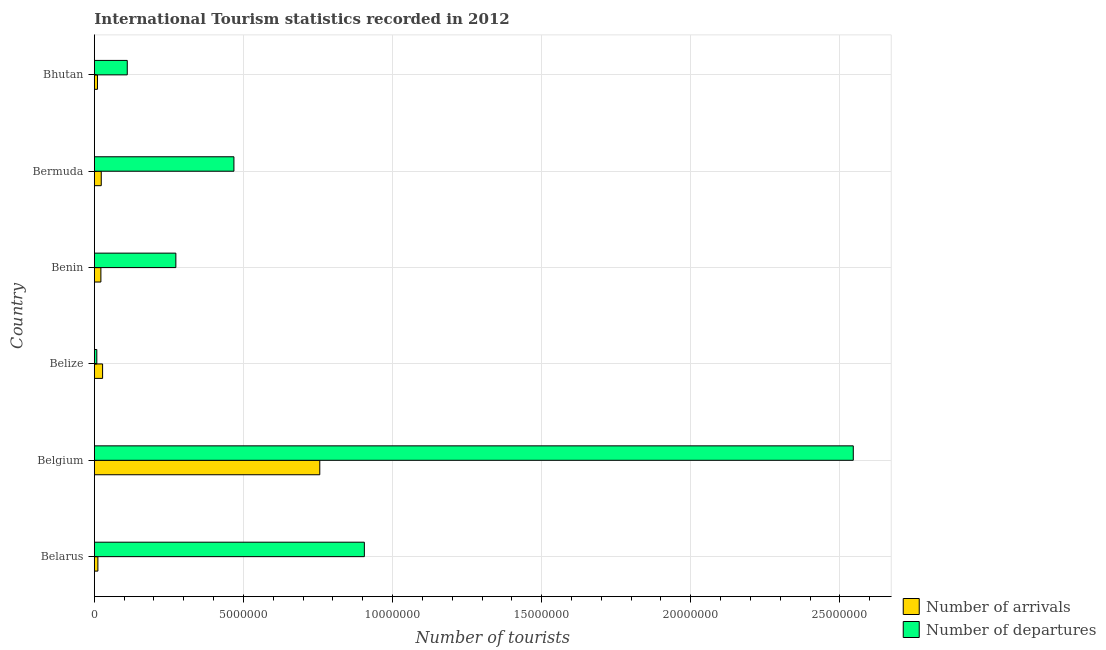How many groups of bars are there?
Your answer should be very brief. 6. Are the number of bars per tick equal to the number of legend labels?
Make the answer very short. Yes. Are the number of bars on each tick of the Y-axis equal?
Ensure brevity in your answer.  Yes. What is the label of the 1st group of bars from the top?
Your response must be concise. Bhutan. What is the number of tourist arrivals in Bermuda?
Your answer should be very brief. 2.32e+05. Across all countries, what is the maximum number of tourist arrivals?
Your response must be concise. 7.56e+06. Across all countries, what is the minimum number of tourist departures?
Your answer should be compact. 8.30e+04. In which country was the number of tourist arrivals maximum?
Ensure brevity in your answer.  Belgium. In which country was the number of tourist arrivals minimum?
Your answer should be compact. Bhutan. What is the total number of tourist arrivals in the graph?
Make the answer very short. 8.51e+06. What is the difference between the number of tourist departures in Belgium and that in Bermuda?
Make the answer very short. 2.08e+07. What is the difference between the number of tourist arrivals in Bermuda and the number of tourist departures in Belgium?
Offer a very short reply. -2.52e+07. What is the average number of tourist departures per country?
Your response must be concise. 7.18e+06. What is the difference between the number of tourist departures and number of tourist arrivals in Bhutan?
Give a very brief answer. 9.99e+05. In how many countries, is the number of tourist arrivals greater than 9000000 ?
Your response must be concise. 0. What is the ratio of the number of tourist departures in Bermuda to that in Bhutan?
Offer a very short reply. 4.24. What is the difference between the highest and the second highest number of tourist departures?
Keep it short and to the point. 1.64e+07. What is the difference between the highest and the lowest number of tourist departures?
Give a very brief answer. 2.54e+07. In how many countries, is the number of tourist departures greater than the average number of tourist departures taken over all countries?
Provide a short and direct response. 2. Is the sum of the number of tourist arrivals in Belarus and Benin greater than the maximum number of tourist departures across all countries?
Give a very brief answer. No. What does the 2nd bar from the top in Belize represents?
Provide a short and direct response. Number of arrivals. What does the 1st bar from the bottom in Bhutan represents?
Your answer should be very brief. Number of arrivals. How many bars are there?
Provide a short and direct response. 12. What is the difference between two consecutive major ticks on the X-axis?
Offer a terse response. 5.00e+06. Does the graph contain grids?
Provide a short and direct response. Yes. Where does the legend appear in the graph?
Your answer should be very brief. Bottom right. What is the title of the graph?
Ensure brevity in your answer.  International Tourism statistics recorded in 2012. Does "current US$" appear as one of the legend labels in the graph?
Keep it short and to the point. No. What is the label or title of the X-axis?
Your response must be concise. Number of tourists. What is the label or title of the Y-axis?
Offer a terse response. Country. What is the Number of tourists in Number of arrivals in Belarus?
Provide a short and direct response. 1.19e+05. What is the Number of tourists of Number of departures in Belarus?
Ensure brevity in your answer.  9.06e+06. What is the Number of tourists in Number of arrivals in Belgium?
Keep it short and to the point. 7.56e+06. What is the Number of tourists in Number of departures in Belgium?
Your answer should be compact. 2.54e+07. What is the Number of tourists of Number of arrivals in Belize?
Provide a short and direct response. 2.77e+05. What is the Number of tourists in Number of departures in Belize?
Ensure brevity in your answer.  8.30e+04. What is the Number of tourists in Number of departures in Benin?
Make the answer very short. 2.73e+06. What is the Number of tourists of Number of arrivals in Bermuda?
Your answer should be very brief. 2.32e+05. What is the Number of tourists of Number of departures in Bermuda?
Your answer should be compact. 4.68e+06. What is the Number of tourists of Number of arrivals in Bhutan?
Offer a terse response. 1.05e+05. What is the Number of tourists of Number of departures in Bhutan?
Offer a very short reply. 1.10e+06. Across all countries, what is the maximum Number of tourists of Number of arrivals?
Give a very brief answer. 7.56e+06. Across all countries, what is the maximum Number of tourists of Number of departures?
Make the answer very short. 2.54e+07. Across all countries, what is the minimum Number of tourists in Number of arrivals?
Offer a terse response. 1.05e+05. Across all countries, what is the minimum Number of tourists of Number of departures?
Keep it short and to the point. 8.30e+04. What is the total Number of tourists of Number of arrivals in the graph?
Your response must be concise. 8.51e+06. What is the total Number of tourists of Number of departures in the graph?
Offer a terse response. 4.31e+07. What is the difference between the Number of tourists of Number of arrivals in Belarus and that in Belgium?
Your response must be concise. -7.44e+06. What is the difference between the Number of tourists in Number of departures in Belarus and that in Belgium?
Provide a succinct answer. -1.64e+07. What is the difference between the Number of tourists of Number of arrivals in Belarus and that in Belize?
Offer a very short reply. -1.58e+05. What is the difference between the Number of tourists of Number of departures in Belarus and that in Belize?
Provide a succinct answer. 8.97e+06. What is the difference between the Number of tourists in Number of arrivals in Belarus and that in Benin?
Ensure brevity in your answer.  -1.01e+05. What is the difference between the Number of tourists in Number of departures in Belarus and that in Benin?
Offer a terse response. 6.32e+06. What is the difference between the Number of tourists in Number of arrivals in Belarus and that in Bermuda?
Provide a short and direct response. -1.13e+05. What is the difference between the Number of tourists in Number of departures in Belarus and that in Bermuda?
Your answer should be compact. 4.37e+06. What is the difference between the Number of tourists in Number of arrivals in Belarus and that in Bhutan?
Offer a terse response. 1.40e+04. What is the difference between the Number of tourists of Number of departures in Belarus and that in Bhutan?
Make the answer very short. 7.95e+06. What is the difference between the Number of tourists of Number of arrivals in Belgium and that in Belize?
Offer a very short reply. 7.28e+06. What is the difference between the Number of tourists of Number of departures in Belgium and that in Belize?
Keep it short and to the point. 2.54e+07. What is the difference between the Number of tourists of Number of arrivals in Belgium and that in Benin?
Ensure brevity in your answer.  7.34e+06. What is the difference between the Number of tourists of Number of departures in Belgium and that in Benin?
Ensure brevity in your answer.  2.27e+07. What is the difference between the Number of tourists of Number of arrivals in Belgium and that in Bermuda?
Provide a succinct answer. 7.33e+06. What is the difference between the Number of tourists of Number of departures in Belgium and that in Bermuda?
Your answer should be compact. 2.08e+07. What is the difference between the Number of tourists of Number of arrivals in Belgium and that in Bhutan?
Provide a short and direct response. 7.46e+06. What is the difference between the Number of tourists of Number of departures in Belgium and that in Bhutan?
Keep it short and to the point. 2.43e+07. What is the difference between the Number of tourists of Number of arrivals in Belize and that in Benin?
Provide a short and direct response. 5.70e+04. What is the difference between the Number of tourists in Number of departures in Belize and that in Benin?
Your response must be concise. -2.65e+06. What is the difference between the Number of tourists in Number of arrivals in Belize and that in Bermuda?
Give a very brief answer. 4.50e+04. What is the difference between the Number of tourists in Number of departures in Belize and that in Bermuda?
Your answer should be very brief. -4.60e+06. What is the difference between the Number of tourists of Number of arrivals in Belize and that in Bhutan?
Offer a very short reply. 1.72e+05. What is the difference between the Number of tourists of Number of departures in Belize and that in Bhutan?
Your response must be concise. -1.02e+06. What is the difference between the Number of tourists of Number of arrivals in Benin and that in Bermuda?
Provide a short and direct response. -1.20e+04. What is the difference between the Number of tourists of Number of departures in Benin and that in Bermuda?
Offer a terse response. -1.95e+06. What is the difference between the Number of tourists in Number of arrivals in Benin and that in Bhutan?
Offer a terse response. 1.15e+05. What is the difference between the Number of tourists in Number of departures in Benin and that in Bhutan?
Give a very brief answer. 1.63e+06. What is the difference between the Number of tourists of Number of arrivals in Bermuda and that in Bhutan?
Keep it short and to the point. 1.27e+05. What is the difference between the Number of tourists of Number of departures in Bermuda and that in Bhutan?
Your answer should be compact. 3.58e+06. What is the difference between the Number of tourists in Number of arrivals in Belarus and the Number of tourists in Number of departures in Belgium?
Provide a short and direct response. -2.53e+07. What is the difference between the Number of tourists in Number of arrivals in Belarus and the Number of tourists in Number of departures in Belize?
Give a very brief answer. 3.60e+04. What is the difference between the Number of tourists of Number of arrivals in Belarus and the Number of tourists of Number of departures in Benin?
Your response must be concise. -2.62e+06. What is the difference between the Number of tourists of Number of arrivals in Belarus and the Number of tourists of Number of departures in Bermuda?
Provide a succinct answer. -4.56e+06. What is the difference between the Number of tourists in Number of arrivals in Belarus and the Number of tourists in Number of departures in Bhutan?
Make the answer very short. -9.85e+05. What is the difference between the Number of tourists of Number of arrivals in Belgium and the Number of tourists of Number of departures in Belize?
Ensure brevity in your answer.  7.48e+06. What is the difference between the Number of tourists in Number of arrivals in Belgium and the Number of tourists in Number of departures in Benin?
Give a very brief answer. 4.83e+06. What is the difference between the Number of tourists of Number of arrivals in Belgium and the Number of tourists of Number of departures in Bermuda?
Offer a terse response. 2.88e+06. What is the difference between the Number of tourists in Number of arrivals in Belgium and the Number of tourists in Number of departures in Bhutan?
Give a very brief answer. 6.46e+06. What is the difference between the Number of tourists in Number of arrivals in Belize and the Number of tourists in Number of departures in Benin?
Provide a succinct answer. -2.46e+06. What is the difference between the Number of tourists in Number of arrivals in Belize and the Number of tourists in Number of departures in Bermuda?
Your answer should be compact. -4.40e+06. What is the difference between the Number of tourists in Number of arrivals in Belize and the Number of tourists in Number of departures in Bhutan?
Provide a succinct answer. -8.27e+05. What is the difference between the Number of tourists in Number of arrivals in Benin and the Number of tourists in Number of departures in Bermuda?
Provide a succinct answer. -4.46e+06. What is the difference between the Number of tourists of Number of arrivals in Benin and the Number of tourists of Number of departures in Bhutan?
Your answer should be compact. -8.84e+05. What is the difference between the Number of tourists of Number of arrivals in Bermuda and the Number of tourists of Number of departures in Bhutan?
Provide a succinct answer. -8.72e+05. What is the average Number of tourists of Number of arrivals per country?
Ensure brevity in your answer.  1.42e+06. What is the average Number of tourists of Number of departures per country?
Offer a very short reply. 7.18e+06. What is the difference between the Number of tourists of Number of arrivals and Number of tourists of Number of departures in Belarus?
Provide a short and direct response. -8.94e+06. What is the difference between the Number of tourists of Number of arrivals and Number of tourists of Number of departures in Belgium?
Make the answer very short. -1.79e+07. What is the difference between the Number of tourists in Number of arrivals and Number of tourists in Number of departures in Belize?
Provide a succinct answer. 1.94e+05. What is the difference between the Number of tourists of Number of arrivals and Number of tourists of Number of departures in Benin?
Provide a short and direct response. -2.51e+06. What is the difference between the Number of tourists in Number of arrivals and Number of tourists in Number of departures in Bermuda?
Offer a very short reply. -4.45e+06. What is the difference between the Number of tourists in Number of arrivals and Number of tourists in Number of departures in Bhutan?
Keep it short and to the point. -9.99e+05. What is the ratio of the Number of tourists in Number of arrivals in Belarus to that in Belgium?
Ensure brevity in your answer.  0.02. What is the ratio of the Number of tourists of Number of departures in Belarus to that in Belgium?
Ensure brevity in your answer.  0.36. What is the ratio of the Number of tourists of Number of arrivals in Belarus to that in Belize?
Offer a terse response. 0.43. What is the ratio of the Number of tourists of Number of departures in Belarus to that in Belize?
Make the answer very short. 109.1. What is the ratio of the Number of tourists in Number of arrivals in Belarus to that in Benin?
Give a very brief answer. 0.54. What is the ratio of the Number of tourists of Number of departures in Belarus to that in Benin?
Provide a succinct answer. 3.31. What is the ratio of the Number of tourists in Number of arrivals in Belarus to that in Bermuda?
Your answer should be compact. 0.51. What is the ratio of the Number of tourists in Number of departures in Belarus to that in Bermuda?
Keep it short and to the point. 1.93. What is the ratio of the Number of tourists in Number of arrivals in Belarus to that in Bhutan?
Give a very brief answer. 1.13. What is the ratio of the Number of tourists of Number of departures in Belarus to that in Bhutan?
Keep it short and to the point. 8.2. What is the ratio of the Number of tourists of Number of arrivals in Belgium to that in Belize?
Provide a short and direct response. 27.29. What is the ratio of the Number of tourists in Number of departures in Belgium to that in Belize?
Make the answer very short. 306.63. What is the ratio of the Number of tourists of Number of arrivals in Belgium to that in Benin?
Provide a succinct answer. 34.36. What is the ratio of the Number of tourists of Number of departures in Belgium to that in Benin?
Offer a terse response. 9.31. What is the ratio of the Number of tourists of Number of arrivals in Belgium to that in Bermuda?
Offer a terse response. 32.59. What is the ratio of the Number of tourists in Number of departures in Belgium to that in Bermuda?
Your response must be concise. 5.44. What is the ratio of the Number of tourists of Number of arrivals in Belgium to that in Bhutan?
Your answer should be very brief. 72. What is the ratio of the Number of tourists in Number of departures in Belgium to that in Bhutan?
Provide a succinct answer. 23.05. What is the ratio of the Number of tourists in Number of arrivals in Belize to that in Benin?
Your response must be concise. 1.26. What is the ratio of the Number of tourists of Number of departures in Belize to that in Benin?
Your answer should be compact. 0.03. What is the ratio of the Number of tourists in Number of arrivals in Belize to that in Bermuda?
Your answer should be very brief. 1.19. What is the ratio of the Number of tourists in Number of departures in Belize to that in Bermuda?
Keep it short and to the point. 0.02. What is the ratio of the Number of tourists of Number of arrivals in Belize to that in Bhutan?
Give a very brief answer. 2.64. What is the ratio of the Number of tourists in Number of departures in Belize to that in Bhutan?
Offer a very short reply. 0.08. What is the ratio of the Number of tourists in Number of arrivals in Benin to that in Bermuda?
Provide a succinct answer. 0.95. What is the ratio of the Number of tourists of Number of departures in Benin to that in Bermuda?
Your response must be concise. 0.58. What is the ratio of the Number of tourists in Number of arrivals in Benin to that in Bhutan?
Make the answer very short. 2.1. What is the ratio of the Number of tourists of Number of departures in Benin to that in Bhutan?
Give a very brief answer. 2.48. What is the ratio of the Number of tourists of Number of arrivals in Bermuda to that in Bhutan?
Give a very brief answer. 2.21. What is the ratio of the Number of tourists of Number of departures in Bermuda to that in Bhutan?
Your answer should be compact. 4.24. What is the difference between the highest and the second highest Number of tourists in Number of arrivals?
Ensure brevity in your answer.  7.28e+06. What is the difference between the highest and the second highest Number of tourists in Number of departures?
Ensure brevity in your answer.  1.64e+07. What is the difference between the highest and the lowest Number of tourists in Number of arrivals?
Provide a short and direct response. 7.46e+06. What is the difference between the highest and the lowest Number of tourists of Number of departures?
Make the answer very short. 2.54e+07. 